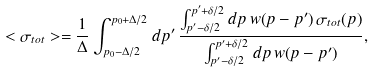Convert formula to latex. <formula><loc_0><loc_0><loc_500><loc_500>< \sigma _ { t o t } > = \frac { 1 } { \Delta } \int _ { p _ { 0 } - \Delta / 2 } ^ { p _ { 0 } + \Delta / 2 } d p ^ { \prime } \, \frac { \int _ { p ^ { \prime } - \delta / 2 } ^ { p ^ { \prime } + \delta / 2 } d p \, w ( p - p ^ { \prime } ) \, \sigma _ { t o t } ( p ) } { \int _ { p ^ { \prime } - \delta / 2 } ^ { p ^ { \prime } + \delta / 2 } d p \, w ( p - p ^ { \prime } ) } ,</formula> 